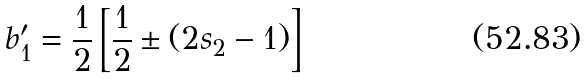Convert formula to latex. <formula><loc_0><loc_0><loc_500><loc_500>b _ { 1 } ^ { \prime } = \frac { 1 } { 2 } \left [ \frac { 1 } { 2 } \pm ( 2 s _ { 2 } - 1 ) \right ]</formula> 